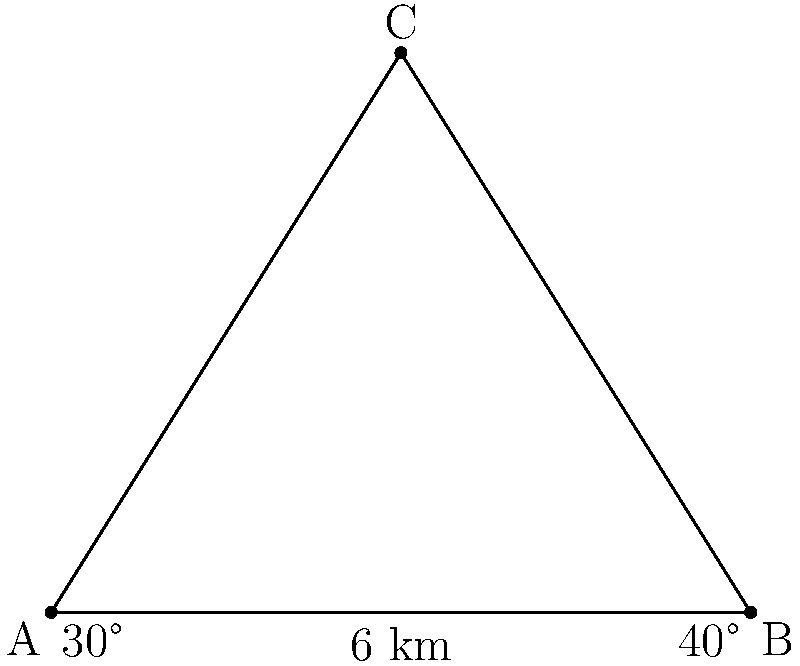As you explore your new diplomatic post, you're intrigued by two landmark buildings in the city center. Your local guide informs you that the distance between these buildings (points A and B) is 6 km. From a vantage point (C), you observe that the angle between the lines of sight to buildings A and B is 110°. The angle between the line AC and AB is 30°, while the angle between BC and BA is 40°. What is the distance between your vantage point (C) and building A? Let's approach this step-by-step using the law of sines:

1) In triangle ABC, we know:
   - Side c (AB) = 6 km
   - Angle A = 30°
   - Angle B = 40°
   - Angle C = 180° - (30° + 40°) = 110°

2) The law of sines states: 
   $$\frac{a}{\sin A} = \frac{b}{\sin B} = \frac{c}{\sin C}$$

3) We want to find side a (AC). We can use:
   $$\frac{a}{\sin A} = \frac{c}{\sin C}$$

4) Rearranging to solve for a:
   $$a = \frac{c \sin A}{\sin C}$$

5) Plugging in the values:
   $$a = \frac{6 \sin 30°}{\sin 110°}$$

6) Calculate:
   $$a = \frac{6 * 0.5}{0.9397} \approx 3.19 \text{ km}$$

Therefore, the distance between your vantage point (C) and building A is approximately 3.19 km.
Answer: 3.19 km 